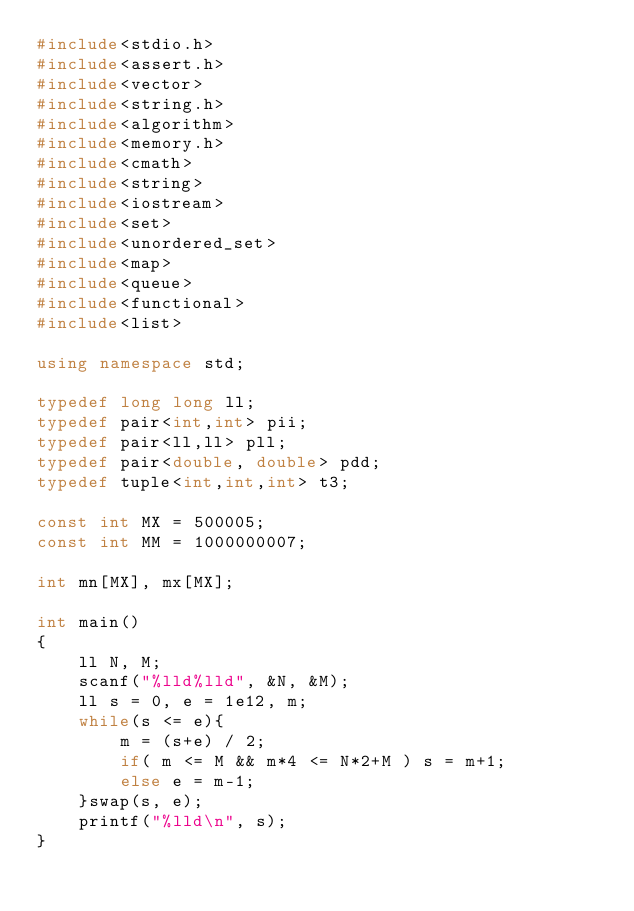<code> <loc_0><loc_0><loc_500><loc_500><_C++_>#include<stdio.h>
#include<assert.h>
#include<vector>
#include<string.h>
#include<algorithm>
#include<memory.h>
#include<cmath>
#include<string>
#include<iostream>
#include<set>
#include<unordered_set>
#include<map>
#include<queue>
#include<functional>
#include<list>

using namespace std;

typedef long long ll;
typedef pair<int,int> pii;
typedef pair<ll,ll> pll;
typedef pair<double, double> pdd;
typedef tuple<int,int,int> t3;

const int MX = 500005;
const int MM = 1000000007;

int mn[MX], mx[MX];

int main()
{
	ll N, M;
	scanf("%lld%lld", &N, &M);
	ll s = 0, e = 1e12, m;
	while(s <= e){
		m = (s+e) / 2;
		if( m <= M && m*4 <= N*2+M ) s = m+1;
		else e = m-1;
	}swap(s, e);
	printf("%lld\n", s);
}
</code> 